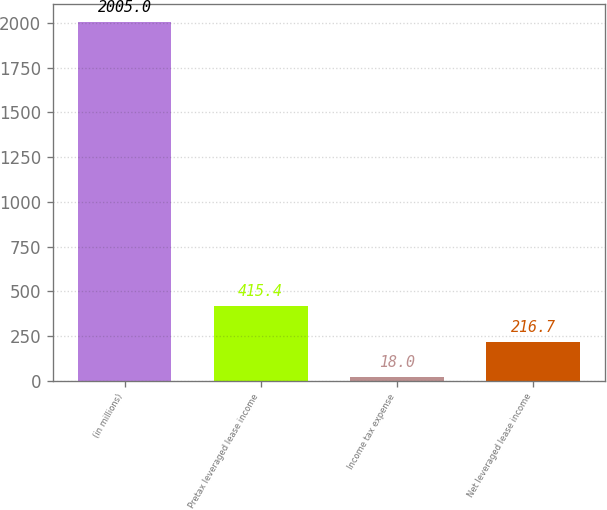Convert chart. <chart><loc_0><loc_0><loc_500><loc_500><bar_chart><fcel>(in millions)<fcel>Pretax leveraged lease income<fcel>Income tax expense<fcel>Net leveraged lease income<nl><fcel>2005<fcel>415.4<fcel>18<fcel>216.7<nl></chart> 